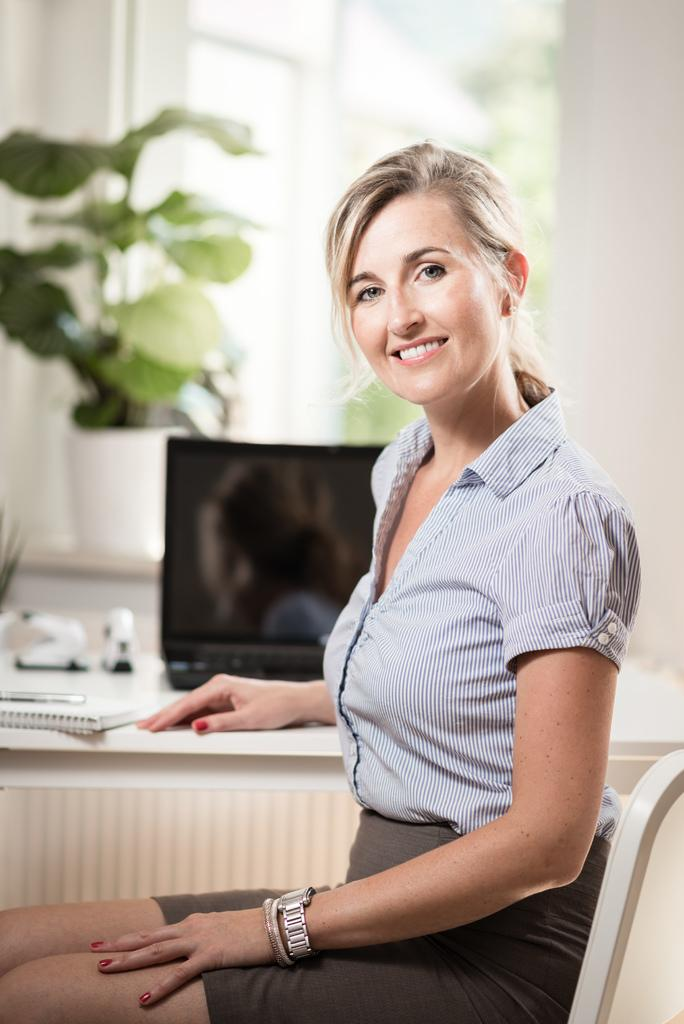What is the main subject of the image? There is a beautiful woman in the image. What is the woman doing in the image? The woman is sitting on a chair. What accessory is the woman wearing in the image? The woman is wearing a watch. What electronic device is present in the image? There is a laptop in the image. What type of plant can be seen in the image? There is a plant in the image. What is the woman's facial expression in the image? The woman is smiling. What type of coach can be seen in the image? There is no coach present in the image. What arithmetic problem is the woman solving in the image? There is no arithmetic problem visible in the image. 